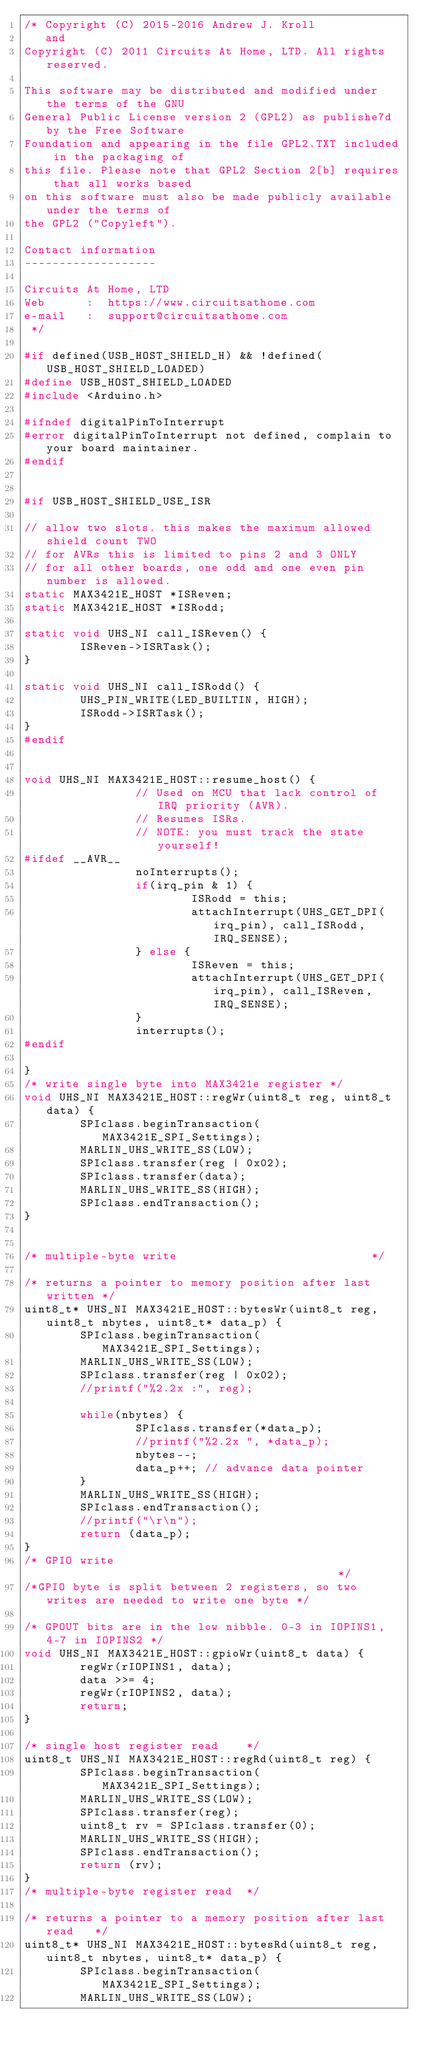Convert code to text. <code><loc_0><loc_0><loc_500><loc_500><_C_>/* Copyright (C) 2015-2016 Andrew J. Kroll
   and
Copyright (C) 2011 Circuits At Home, LTD. All rights reserved.

This software may be distributed and modified under the terms of the GNU
General Public License version 2 (GPL2) as publishe7d by the Free Software
Foundation and appearing in the file GPL2.TXT included in the packaging of
this file. Please note that GPL2 Section 2[b] requires that all works based
on this software must also be made publicly available under the terms of
the GPL2 ("Copyleft").

Contact information
-------------------

Circuits At Home, LTD
Web      :  https://www.circuitsathome.com
e-mail   :  support@circuitsathome.com
 */

#if defined(USB_HOST_SHIELD_H) && !defined(USB_HOST_SHIELD_LOADED)
#define USB_HOST_SHIELD_LOADED
#include <Arduino.h>

#ifndef digitalPinToInterrupt
#error digitalPinToInterrupt not defined, complain to your board maintainer.
#endif


#if USB_HOST_SHIELD_USE_ISR

// allow two slots. this makes the maximum allowed shield count TWO
// for AVRs this is limited to pins 2 and 3 ONLY
// for all other boards, one odd and one even pin number is allowed.
static MAX3421E_HOST *ISReven;
static MAX3421E_HOST *ISRodd;

static void UHS_NI call_ISReven() {
        ISReven->ISRTask();
}

static void UHS_NI call_ISRodd() {
        UHS_PIN_WRITE(LED_BUILTIN, HIGH);
        ISRodd->ISRTask();
}
#endif


void UHS_NI MAX3421E_HOST::resume_host() {
                // Used on MCU that lack control of IRQ priority (AVR).
                // Resumes ISRs.
                // NOTE: you must track the state yourself!
#ifdef __AVR__
                noInterrupts();
                if(irq_pin & 1) {
                        ISRodd = this;
                        attachInterrupt(UHS_GET_DPI(irq_pin), call_ISRodd, IRQ_SENSE);
                } else {
                        ISReven = this;
                        attachInterrupt(UHS_GET_DPI(irq_pin), call_ISReven, IRQ_SENSE);
                }
                interrupts();
#endif

}
/* write single byte into MAX3421e register */
void UHS_NI MAX3421E_HOST::regWr(uint8_t reg, uint8_t data) {
        SPIclass.beginTransaction(MAX3421E_SPI_Settings);
        MARLIN_UHS_WRITE_SS(LOW);
        SPIclass.transfer(reg | 0x02);
        SPIclass.transfer(data);
        MARLIN_UHS_WRITE_SS(HIGH);
        SPIclass.endTransaction();
}


/* multiple-byte write                            */

/* returns a pointer to memory position after last written */
uint8_t* UHS_NI MAX3421E_HOST::bytesWr(uint8_t reg, uint8_t nbytes, uint8_t* data_p) {
        SPIclass.beginTransaction(MAX3421E_SPI_Settings);
        MARLIN_UHS_WRITE_SS(LOW);
        SPIclass.transfer(reg | 0x02);
        //printf("%2.2x :", reg);

        while(nbytes) {
                SPIclass.transfer(*data_p);
                //printf("%2.2x ", *data_p);
                nbytes--;
                data_p++; // advance data pointer
        }
        MARLIN_UHS_WRITE_SS(HIGH);
        SPIclass.endTransaction();
        //printf("\r\n");
        return (data_p);
}
/* GPIO write                                           */
/*GPIO byte is split between 2 registers, so two writes are needed to write one byte */

/* GPOUT bits are in the low nibble. 0-3 in IOPINS1, 4-7 in IOPINS2 */
void UHS_NI MAX3421E_HOST::gpioWr(uint8_t data) {
        regWr(rIOPINS1, data);
        data >>= 4;
        regWr(rIOPINS2, data);
        return;
}

/* single host register read    */
uint8_t UHS_NI MAX3421E_HOST::regRd(uint8_t reg) {
        SPIclass.beginTransaction(MAX3421E_SPI_Settings);
        MARLIN_UHS_WRITE_SS(LOW);
        SPIclass.transfer(reg);
        uint8_t rv = SPIclass.transfer(0);
        MARLIN_UHS_WRITE_SS(HIGH);
        SPIclass.endTransaction();
        return (rv);
}
/* multiple-byte register read  */

/* returns a pointer to a memory position after last read   */
uint8_t* UHS_NI MAX3421E_HOST::bytesRd(uint8_t reg, uint8_t nbytes, uint8_t* data_p) {
        SPIclass.beginTransaction(MAX3421E_SPI_Settings);
        MARLIN_UHS_WRITE_SS(LOW);</code> 